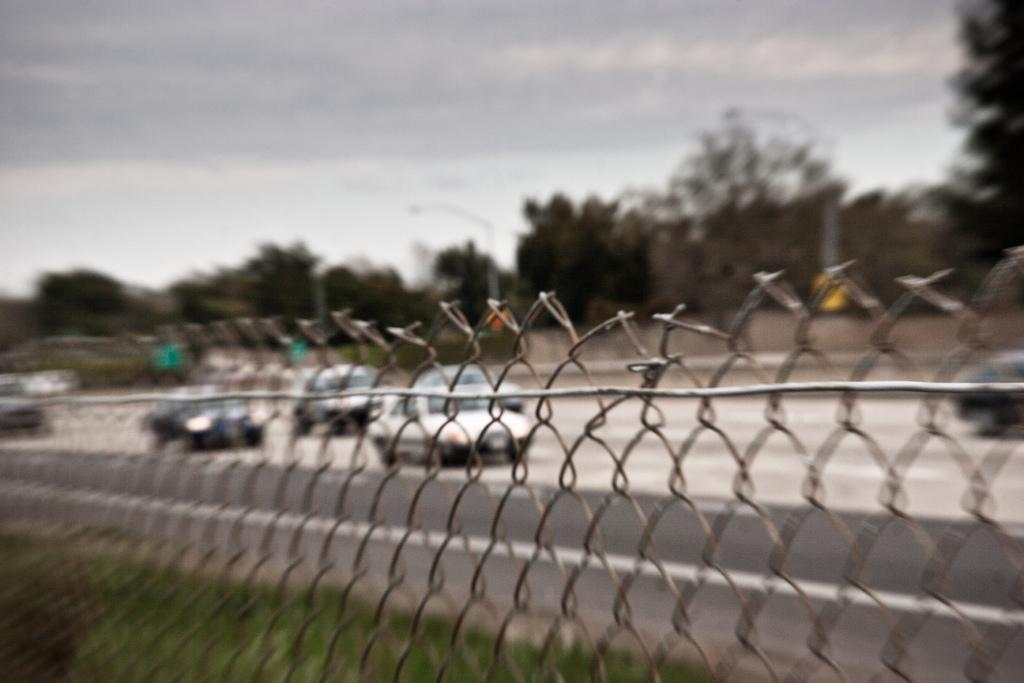What type of barrier can be seen in the image? There is a fence in the image. What type of vegetation is present in the image? There is grass in the image. What can be seen on the road in the image? Vehicles are visible on the road. What is visible in the background of the image? There are many trees, poles, clouds, and the sky in the background of the image. What type of list is being compiled in the image? There is no list being compiled in the image. What type of behavior can be observed in the image? The image does not depict any specific behavior; it shows a fence, grass, vehicles, trees, poles, clouds, and the sky. 